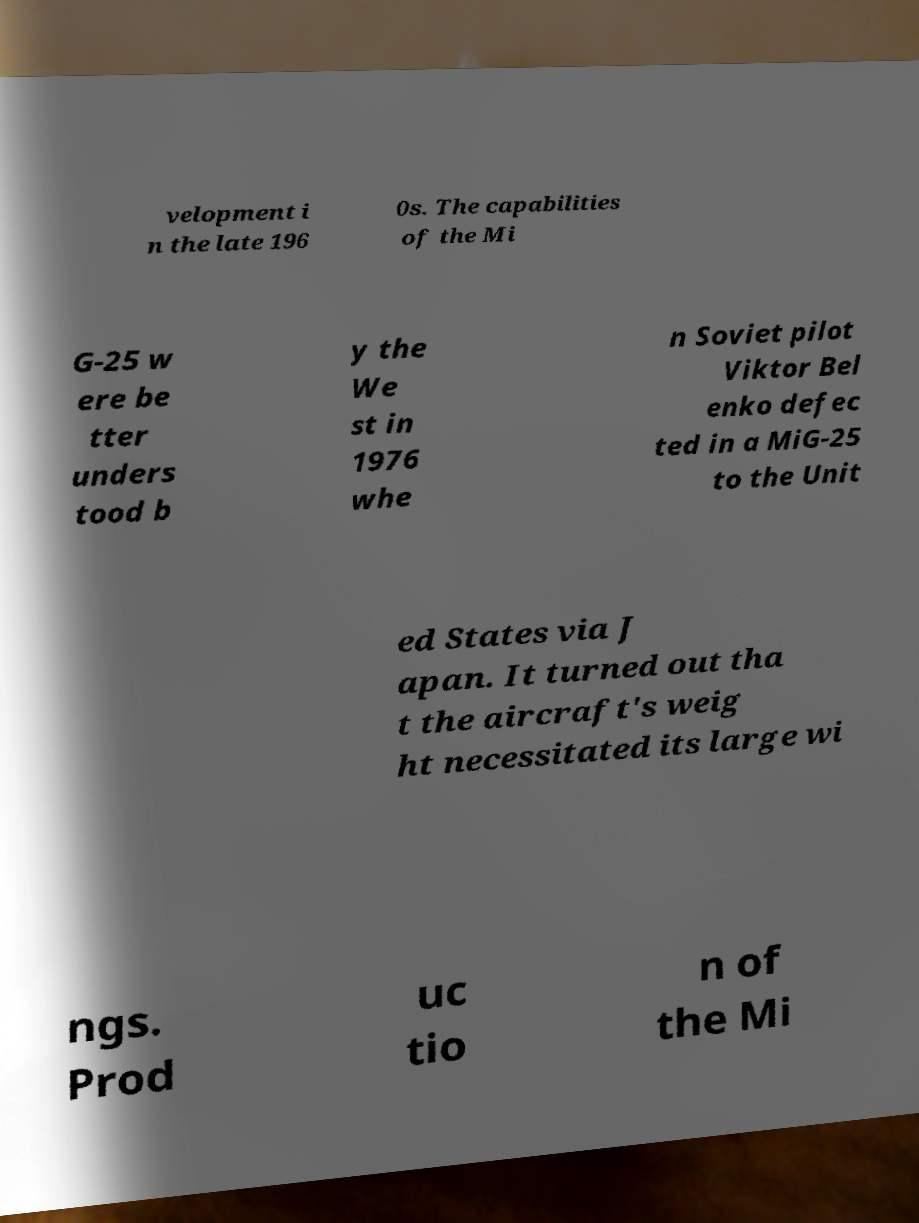Could you assist in decoding the text presented in this image and type it out clearly? velopment i n the late 196 0s. The capabilities of the Mi G-25 w ere be tter unders tood b y the We st in 1976 whe n Soviet pilot Viktor Bel enko defec ted in a MiG-25 to the Unit ed States via J apan. It turned out tha t the aircraft's weig ht necessitated its large wi ngs. Prod uc tio n of the Mi 